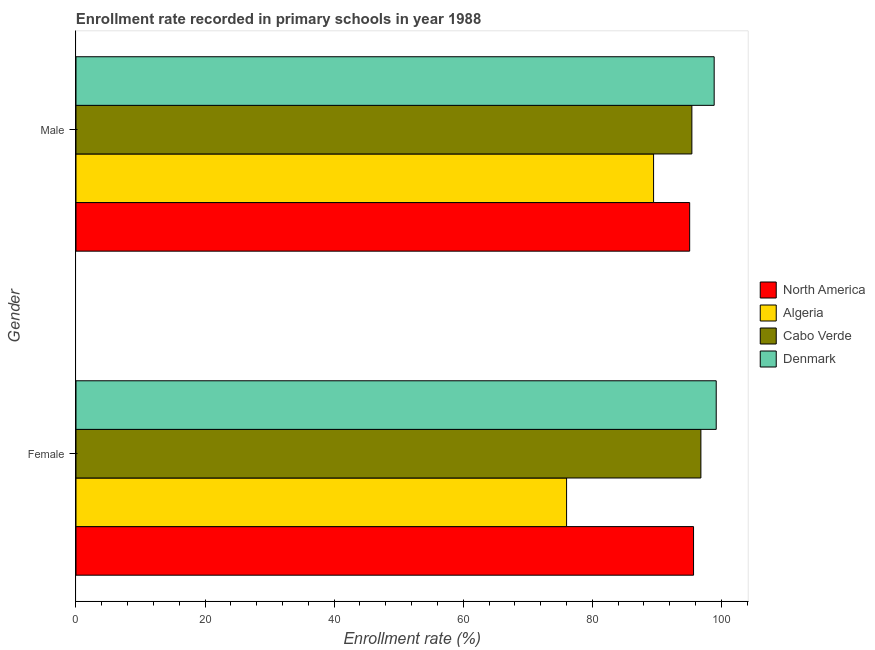How many groups of bars are there?
Provide a succinct answer. 2. Are the number of bars on each tick of the Y-axis equal?
Keep it short and to the point. Yes. How many bars are there on the 2nd tick from the top?
Keep it short and to the point. 4. What is the enrollment rate of male students in North America?
Your answer should be compact. 95.08. Across all countries, what is the maximum enrollment rate of male students?
Keep it short and to the point. 98.88. Across all countries, what is the minimum enrollment rate of male students?
Ensure brevity in your answer.  89.49. In which country was the enrollment rate of female students maximum?
Keep it short and to the point. Denmark. In which country was the enrollment rate of female students minimum?
Ensure brevity in your answer.  Algeria. What is the total enrollment rate of male students in the graph?
Make the answer very short. 378.88. What is the difference between the enrollment rate of female students in Denmark and that in Cabo Verde?
Your response must be concise. 2.37. What is the difference between the enrollment rate of male students in Cabo Verde and the enrollment rate of female students in Denmark?
Ensure brevity in your answer.  -3.77. What is the average enrollment rate of female students per country?
Offer a terse response. 91.93. What is the difference between the enrollment rate of male students and enrollment rate of female students in Denmark?
Keep it short and to the point. -0.32. In how many countries, is the enrollment rate of male students greater than 100 %?
Make the answer very short. 0. What is the ratio of the enrollment rate of female students in Algeria to that in North America?
Ensure brevity in your answer.  0.79. Is the enrollment rate of female students in North America less than that in Denmark?
Your answer should be compact. Yes. In how many countries, is the enrollment rate of female students greater than the average enrollment rate of female students taken over all countries?
Provide a short and direct response. 3. What does the 2nd bar from the top in Male represents?
Give a very brief answer. Cabo Verde. What does the 4th bar from the bottom in Female represents?
Keep it short and to the point. Denmark. Are all the bars in the graph horizontal?
Your answer should be very brief. Yes. How many legend labels are there?
Provide a succinct answer. 4. What is the title of the graph?
Offer a very short reply. Enrollment rate recorded in primary schools in year 1988. What is the label or title of the X-axis?
Make the answer very short. Enrollment rate (%). What is the label or title of the Y-axis?
Your answer should be compact. Gender. What is the Enrollment rate (%) of North America in Female?
Provide a short and direct response. 95.69. What is the Enrollment rate (%) in Algeria in Female?
Your answer should be compact. 76.01. What is the Enrollment rate (%) in Cabo Verde in Female?
Your answer should be compact. 96.82. What is the Enrollment rate (%) of Denmark in Female?
Provide a short and direct response. 99.2. What is the Enrollment rate (%) in North America in Male?
Give a very brief answer. 95.08. What is the Enrollment rate (%) of Algeria in Male?
Ensure brevity in your answer.  89.49. What is the Enrollment rate (%) in Cabo Verde in Male?
Offer a very short reply. 95.43. What is the Enrollment rate (%) in Denmark in Male?
Give a very brief answer. 98.88. Across all Gender, what is the maximum Enrollment rate (%) of North America?
Your answer should be very brief. 95.69. Across all Gender, what is the maximum Enrollment rate (%) of Algeria?
Offer a terse response. 89.49. Across all Gender, what is the maximum Enrollment rate (%) of Cabo Verde?
Ensure brevity in your answer.  96.82. Across all Gender, what is the maximum Enrollment rate (%) of Denmark?
Your answer should be very brief. 99.2. Across all Gender, what is the minimum Enrollment rate (%) in North America?
Your answer should be very brief. 95.08. Across all Gender, what is the minimum Enrollment rate (%) in Algeria?
Your answer should be compact. 76.01. Across all Gender, what is the minimum Enrollment rate (%) of Cabo Verde?
Keep it short and to the point. 95.43. Across all Gender, what is the minimum Enrollment rate (%) in Denmark?
Ensure brevity in your answer.  98.88. What is the total Enrollment rate (%) of North America in the graph?
Your response must be concise. 190.77. What is the total Enrollment rate (%) in Algeria in the graph?
Ensure brevity in your answer.  165.5. What is the total Enrollment rate (%) in Cabo Verde in the graph?
Give a very brief answer. 192.25. What is the total Enrollment rate (%) of Denmark in the graph?
Provide a short and direct response. 198.08. What is the difference between the Enrollment rate (%) of North America in Female and that in Male?
Provide a short and direct response. 0.6. What is the difference between the Enrollment rate (%) of Algeria in Female and that in Male?
Your answer should be compact. -13.48. What is the difference between the Enrollment rate (%) in Cabo Verde in Female and that in Male?
Your answer should be compact. 1.4. What is the difference between the Enrollment rate (%) of Denmark in Female and that in Male?
Make the answer very short. 0.32. What is the difference between the Enrollment rate (%) in North America in Female and the Enrollment rate (%) in Algeria in Male?
Your response must be concise. 6.19. What is the difference between the Enrollment rate (%) in North America in Female and the Enrollment rate (%) in Cabo Verde in Male?
Make the answer very short. 0.26. What is the difference between the Enrollment rate (%) of North America in Female and the Enrollment rate (%) of Denmark in Male?
Your answer should be very brief. -3.2. What is the difference between the Enrollment rate (%) in Algeria in Female and the Enrollment rate (%) in Cabo Verde in Male?
Provide a succinct answer. -19.41. What is the difference between the Enrollment rate (%) of Algeria in Female and the Enrollment rate (%) of Denmark in Male?
Your answer should be very brief. -22.87. What is the difference between the Enrollment rate (%) in Cabo Verde in Female and the Enrollment rate (%) in Denmark in Male?
Keep it short and to the point. -2.06. What is the average Enrollment rate (%) of North America per Gender?
Your response must be concise. 95.38. What is the average Enrollment rate (%) in Algeria per Gender?
Offer a terse response. 82.75. What is the average Enrollment rate (%) of Cabo Verde per Gender?
Give a very brief answer. 96.12. What is the average Enrollment rate (%) in Denmark per Gender?
Your answer should be compact. 99.04. What is the difference between the Enrollment rate (%) of North America and Enrollment rate (%) of Algeria in Female?
Provide a succinct answer. 19.67. What is the difference between the Enrollment rate (%) of North America and Enrollment rate (%) of Cabo Verde in Female?
Your response must be concise. -1.14. What is the difference between the Enrollment rate (%) of North America and Enrollment rate (%) of Denmark in Female?
Keep it short and to the point. -3.51. What is the difference between the Enrollment rate (%) of Algeria and Enrollment rate (%) of Cabo Verde in Female?
Provide a short and direct response. -20.81. What is the difference between the Enrollment rate (%) of Algeria and Enrollment rate (%) of Denmark in Female?
Provide a short and direct response. -23.19. What is the difference between the Enrollment rate (%) of Cabo Verde and Enrollment rate (%) of Denmark in Female?
Your response must be concise. -2.37. What is the difference between the Enrollment rate (%) in North America and Enrollment rate (%) in Algeria in Male?
Offer a very short reply. 5.59. What is the difference between the Enrollment rate (%) of North America and Enrollment rate (%) of Cabo Verde in Male?
Offer a terse response. -0.34. What is the difference between the Enrollment rate (%) in North America and Enrollment rate (%) in Denmark in Male?
Keep it short and to the point. -3.8. What is the difference between the Enrollment rate (%) of Algeria and Enrollment rate (%) of Cabo Verde in Male?
Offer a very short reply. -5.93. What is the difference between the Enrollment rate (%) of Algeria and Enrollment rate (%) of Denmark in Male?
Your answer should be compact. -9.39. What is the difference between the Enrollment rate (%) of Cabo Verde and Enrollment rate (%) of Denmark in Male?
Your answer should be very brief. -3.46. What is the ratio of the Enrollment rate (%) in Algeria in Female to that in Male?
Make the answer very short. 0.85. What is the ratio of the Enrollment rate (%) in Cabo Verde in Female to that in Male?
Provide a succinct answer. 1.01. What is the difference between the highest and the second highest Enrollment rate (%) of North America?
Your response must be concise. 0.6. What is the difference between the highest and the second highest Enrollment rate (%) of Algeria?
Make the answer very short. 13.48. What is the difference between the highest and the second highest Enrollment rate (%) of Cabo Verde?
Give a very brief answer. 1.4. What is the difference between the highest and the second highest Enrollment rate (%) of Denmark?
Keep it short and to the point. 0.32. What is the difference between the highest and the lowest Enrollment rate (%) in North America?
Offer a terse response. 0.6. What is the difference between the highest and the lowest Enrollment rate (%) in Algeria?
Provide a succinct answer. 13.48. What is the difference between the highest and the lowest Enrollment rate (%) of Cabo Verde?
Your response must be concise. 1.4. What is the difference between the highest and the lowest Enrollment rate (%) of Denmark?
Provide a succinct answer. 0.32. 